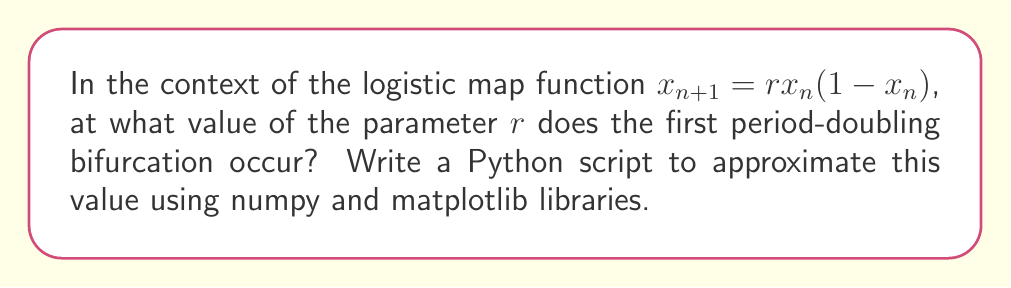Teach me how to tackle this problem. To find the first period-doubling bifurcation in the logistic map, we need to follow these steps:

1. Understand the logistic map:
   The logistic map is defined by the equation $x_{n+1} = rx_n(1-x_n)$, where $r$ is the parameter we're interested in.

2. Recognize the period-doubling behavior:
   As $r$ increases, the system transitions from a stable fixed point to oscillating between two values, then four, and so on.

3. Identify the first bifurcation:
   The first period-doubling occurs when the system transitions from a stable fixed point to oscillating between two values.

4. Theoretical value:
   The exact value for the first bifurcation is $r = 3$.

5. Approximate using Python:
   We can write a script to visualize this transition:

```python
import numpy as np
import matplotlib.pyplot as plt

def logistic_map(r, x0, n):
    x = np.zeros(n)
    x[0] = x0
    for i in range(1, n):
        x[i] = r * x[i-1] * (1 - x[i-1])
    return x

r_range = np.linspace(2.5, 3.5, 1000)
n = 1000
x0 = 0.5

bifurcation_diagram = []

for r in r_range:
    x = logistic_map(r, x0, n)
    bifurcation_diagram.extend([r] * 100 + x[-100:].tolist())

bifurcation_diagram = np.array(bifurcation_diagram)

plt.figure(figsize=(12, 8))
plt.plot(bifurcation_diagram[::2], bifurcation_diagram[1::2], ',k', alpha=0.1, markersize=0.1)
plt.xlabel('r')
plt.ylabel('x')
plt.title('Bifurcation Diagram of Logistic Map')
plt.axvline(x=3, color='r', linestyle='--', label='First bifurcation')
plt.legend()
plt.show()
```

6. Analyze the output:
   The script will generate a bifurcation diagram. The first bifurcation is visible as the point where the single line splits into two, which occurs at $r = 3$.
Answer: $r = 3$ 